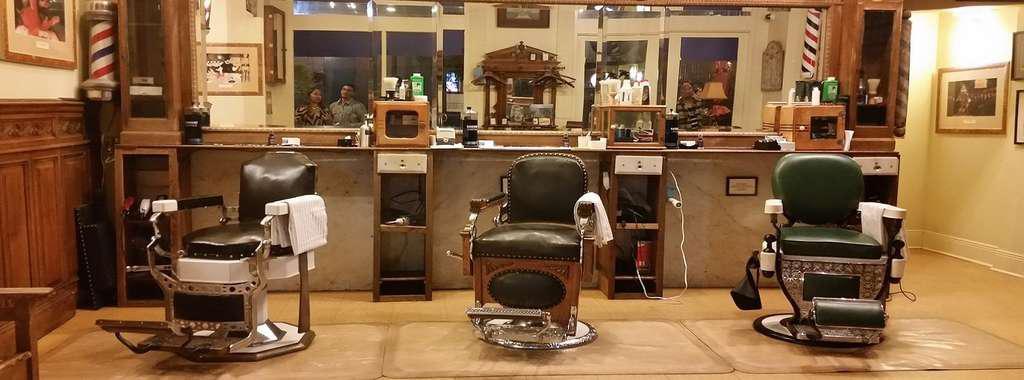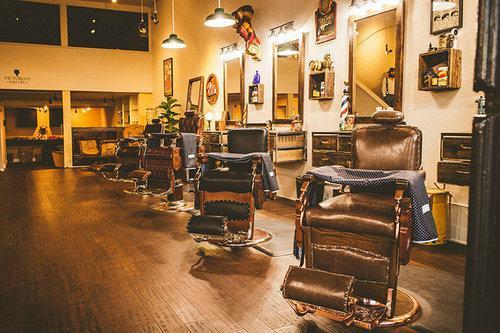The first image is the image on the left, the second image is the image on the right. Given the left and right images, does the statement "In at least one image there are three barber chairs" hold true? Answer yes or no. Yes. The first image is the image on the left, the second image is the image on the right. Examine the images to the left and right. Is the description "The right image shows an empty barber chair turned leftward and facing a horizontal surface piled with items." accurate? Answer yes or no. No. 